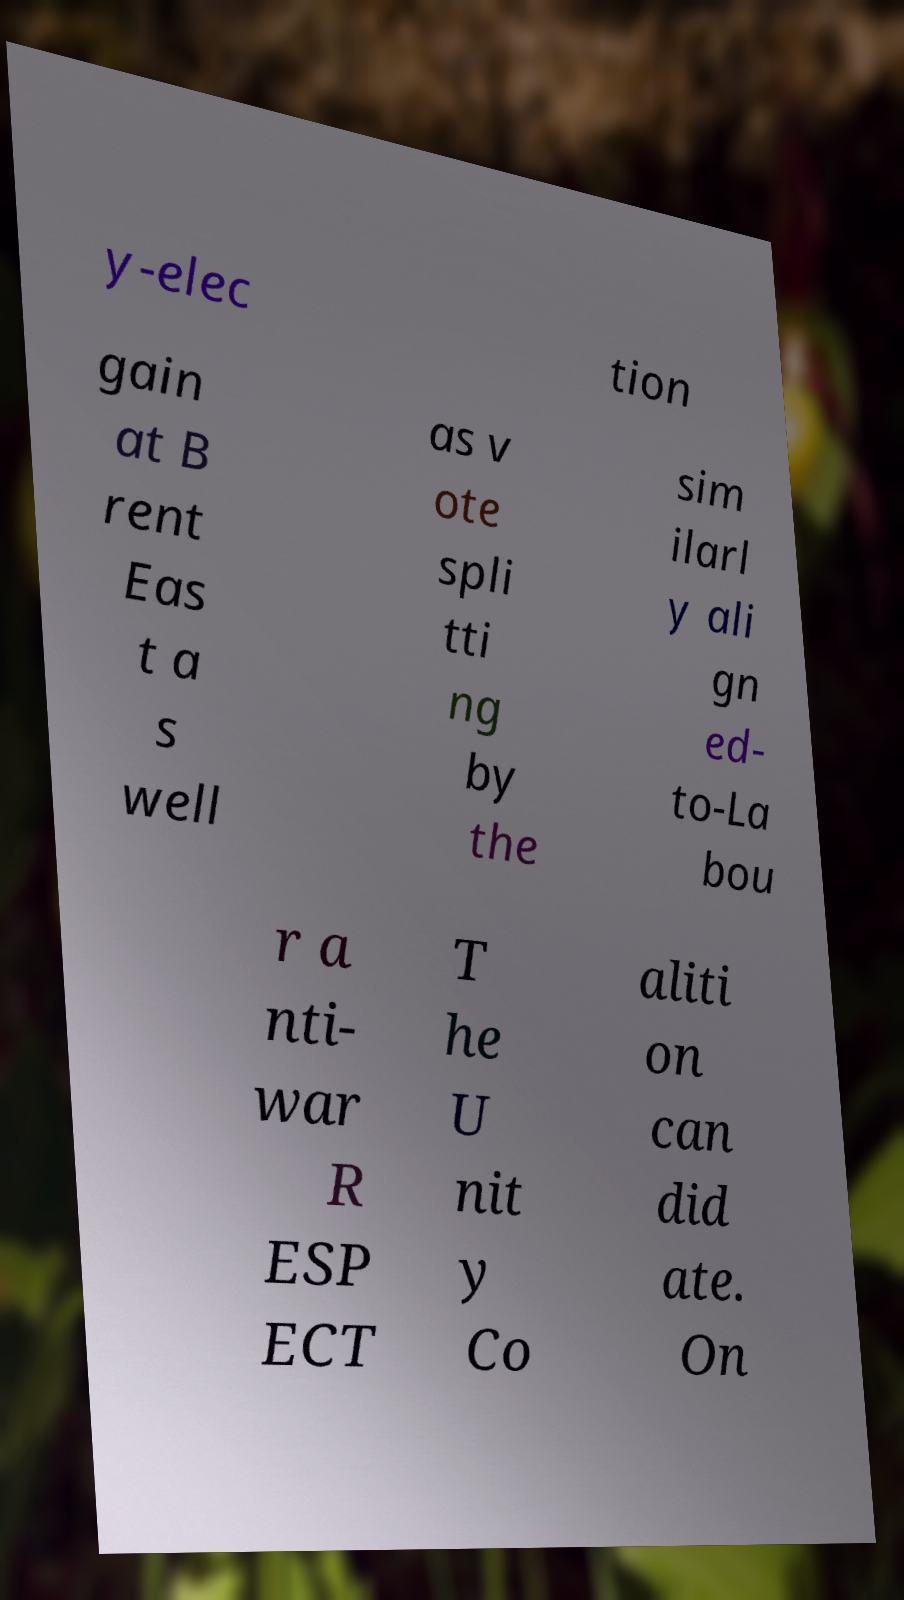Could you extract and type out the text from this image? y-elec tion gain at B rent Eas t a s well as v ote spli tti ng by the sim ilarl y ali gn ed- to-La bou r a nti- war R ESP ECT T he U nit y Co aliti on can did ate. On 